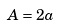<formula> <loc_0><loc_0><loc_500><loc_500>A = 2 a</formula> 